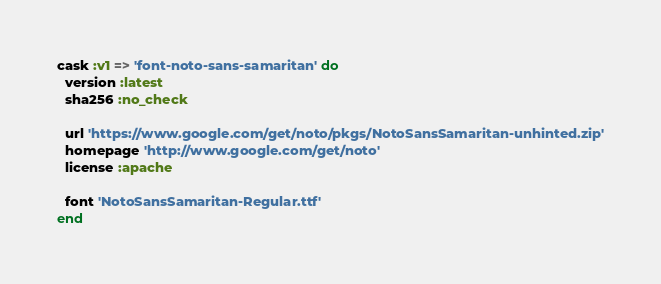Convert code to text. <code><loc_0><loc_0><loc_500><loc_500><_Ruby_>cask :v1 => 'font-noto-sans-samaritan' do
  version :latest
  sha256 :no_check

  url 'https://www.google.com/get/noto/pkgs/NotoSansSamaritan-unhinted.zip'
  homepage 'http://www.google.com/get/noto'
  license :apache

  font 'NotoSansSamaritan-Regular.ttf'
end
</code> 